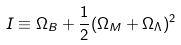<formula> <loc_0><loc_0><loc_500><loc_500>I \equiv \Omega _ { B } + \frac { 1 } { 2 } ( \Omega _ { M } + \Omega _ { \Lambda } ) ^ { 2 }</formula> 